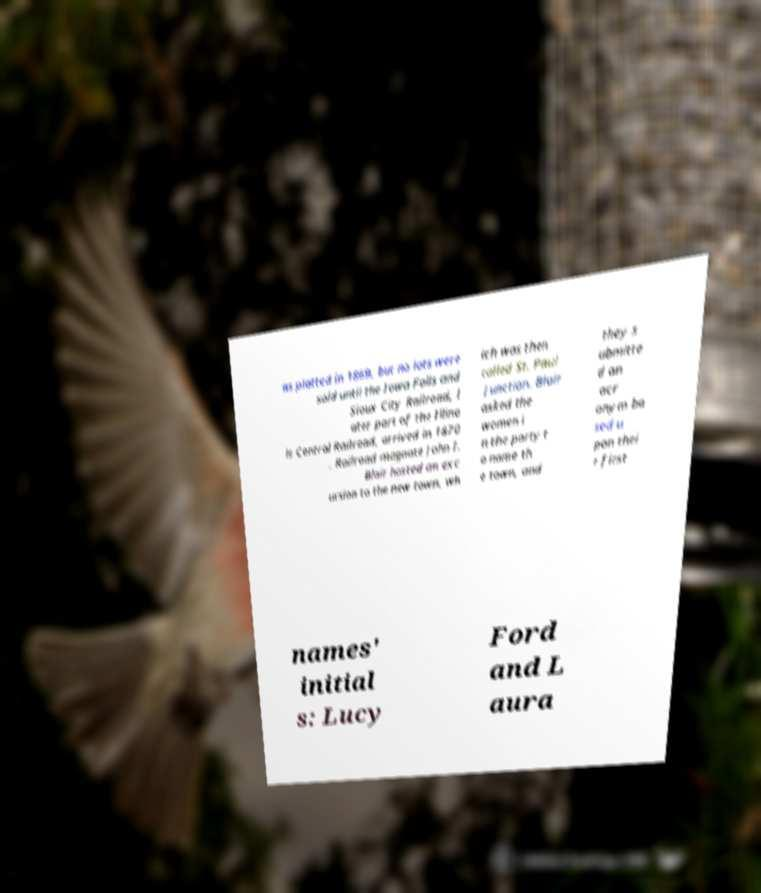Please read and relay the text visible in this image. What does it say? as platted in 1869, but no lots were sold until the Iowa Falls and Sioux City Railroad, l ater part of the Illino is Central Railroad, arrived in 1870 . Railroad magnate John I. Blair hosted an exc ursion to the new town, wh ich was then called St. Paul Junction. Blair asked the women i n the party t o name th e town, and they s ubmitte d an acr onym ba sed u pon thei r first names' initial s: Lucy Ford and L aura 